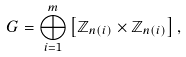Convert formula to latex. <formula><loc_0><loc_0><loc_500><loc_500>G = \bigoplus _ { i = 1 } ^ { m } \left [ \mathbb { Z } _ { n ( i ) } \times \mathbb { Z } _ { n ( i ) } \right ] ,</formula> 